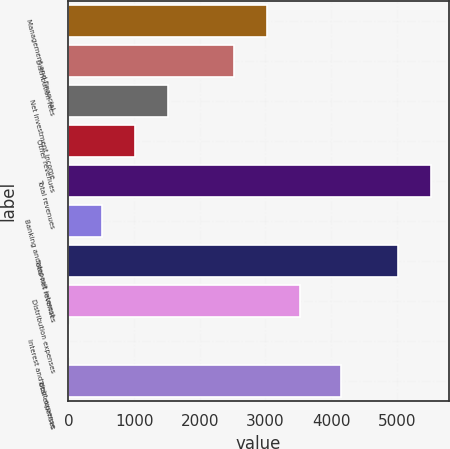Convert chart. <chart><loc_0><loc_0><loc_500><loc_500><bar_chart><fcel>Management and financial<fcel>Distribution fees<fcel>Net investment income<fcel>Other revenues<fcel>Total revenues<fcel>Banking and deposit interest<fcel>Total net revenues<fcel>Distribution expenses<fcel>Interest and debt expense<fcel>Total expenses<nl><fcel>3029<fcel>2525.5<fcel>1518.5<fcel>1015<fcel>5516.5<fcel>511.5<fcel>5013<fcel>3532.5<fcel>8<fcel>4154<nl></chart> 